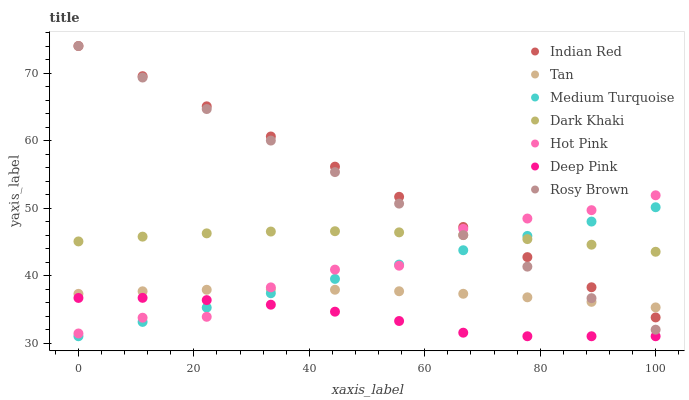Does Deep Pink have the minimum area under the curve?
Answer yes or no. Yes. Does Indian Red have the maximum area under the curve?
Answer yes or no. Yes. Does Hot Pink have the minimum area under the curve?
Answer yes or no. No. Does Hot Pink have the maximum area under the curve?
Answer yes or no. No. Is Rosy Brown the smoothest?
Answer yes or no. Yes. Is Hot Pink the roughest?
Answer yes or no. Yes. Is Indian Red the smoothest?
Answer yes or no. No. Is Indian Red the roughest?
Answer yes or no. No. Does Deep Pink have the lowest value?
Answer yes or no. Yes. Does Indian Red have the lowest value?
Answer yes or no. No. Does Rosy Brown have the highest value?
Answer yes or no. Yes. Does Hot Pink have the highest value?
Answer yes or no. No. Is Deep Pink less than Dark Khaki?
Answer yes or no. Yes. Is Dark Khaki greater than Tan?
Answer yes or no. Yes. Does Dark Khaki intersect Hot Pink?
Answer yes or no. Yes. Is Dark Khaki less than Hot Pink?
Answer yes or no. No. Is Dark Khaki greater than Hot Pink?
Answer yes or no. No. Does Deep Pink intersect Dark Khaki?
Answer yes or no. No. 